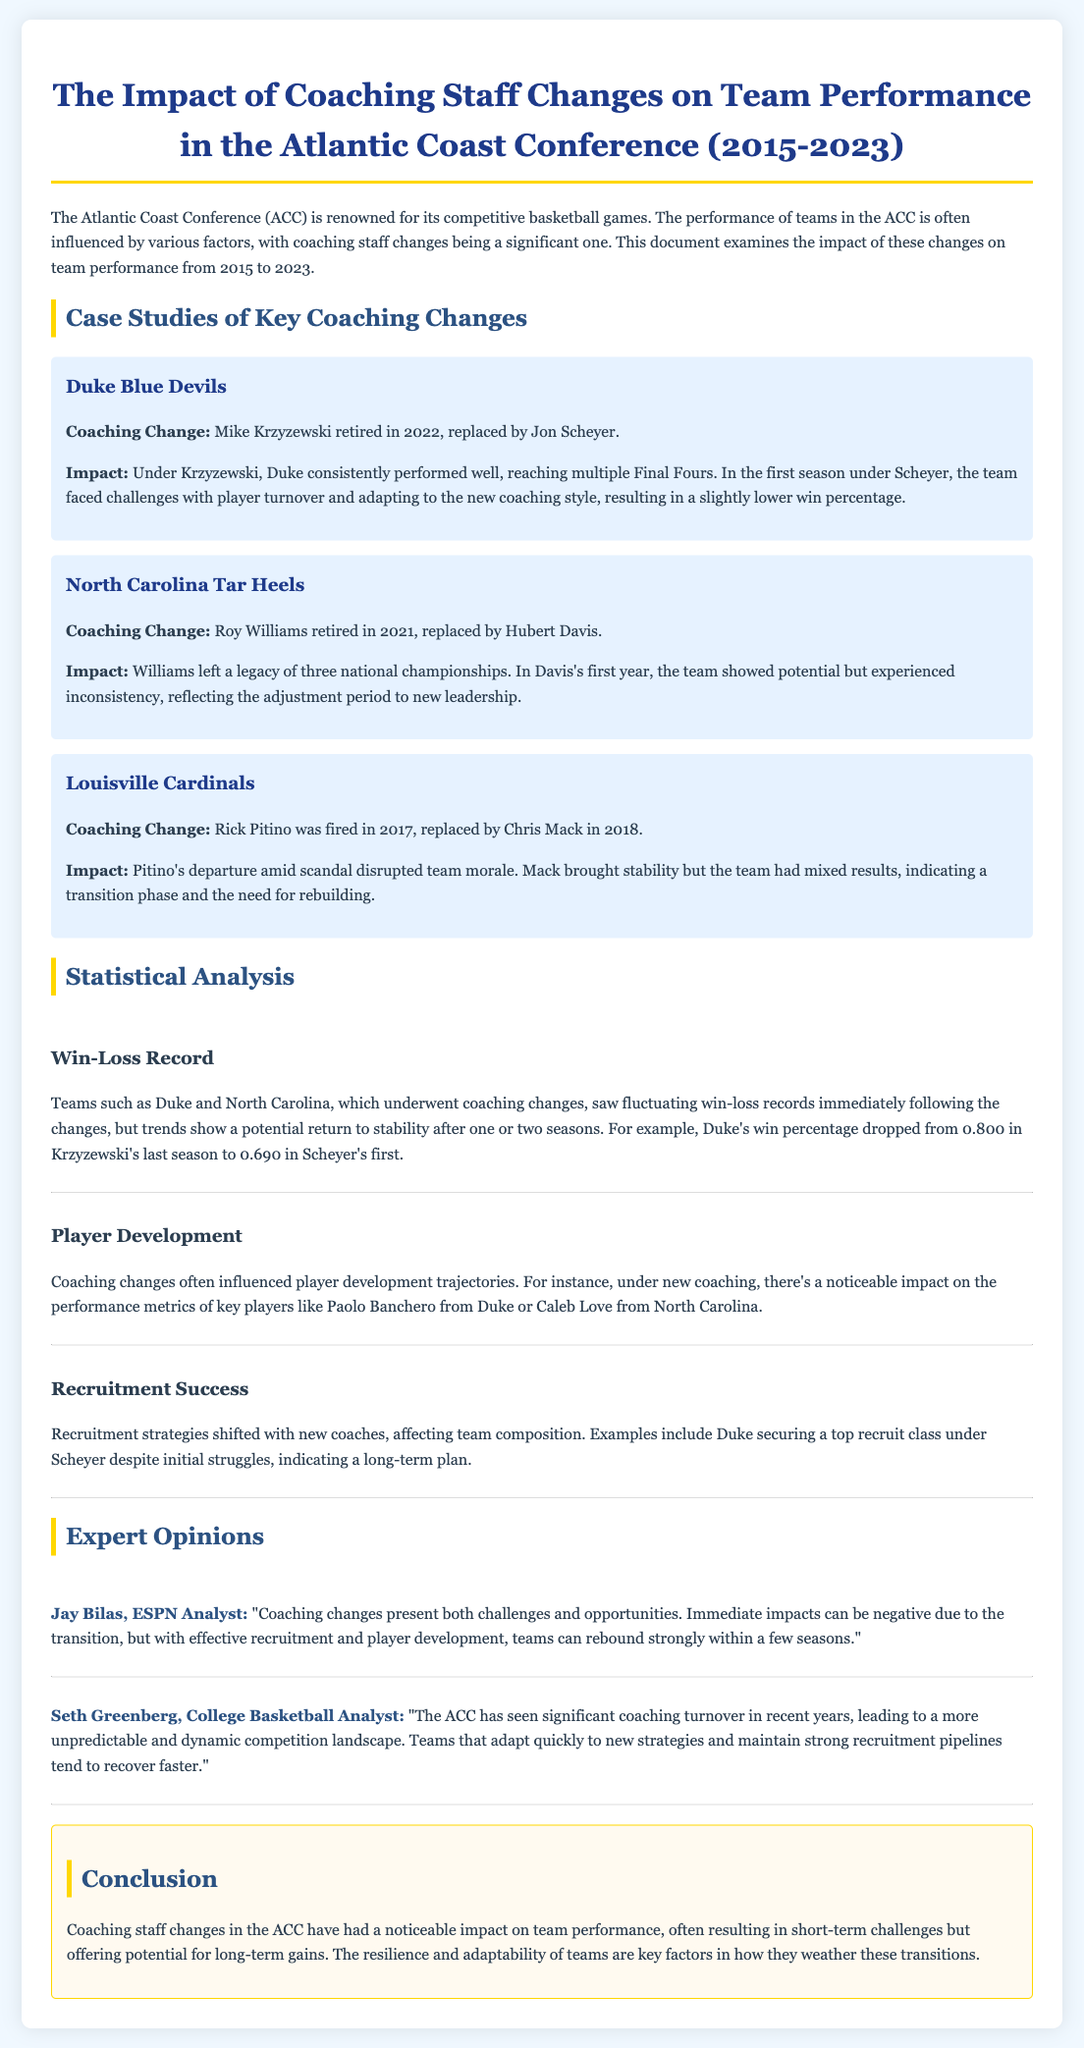what year did Mike Krzyzewski retire? The document states that Mike Krzyzewski retired in 2022.
Answer: 2022 what was Duke's win percentage in Scheyer's first season? According to the document, Duke's win percentage dropped to 0.690 in Scheyer's first season.
Answer: 0.690 how many national championships did Roy Williams win? The document mentions that Roy Williams left a legacy of three national championships.
Answer: three who replaced Rick Pitino as the head coach of Louisville? The document states that Chris Mack replaced Rick Pitino in 2018.
Answer: Chris Mack what did Jay Bilas say about coaching changes? According to Jay Bilas, coaching changes present both challenges and opportunities.
Answer: challenges and opportunities what impact did coaching changes have on player development? The document indicates that coaching changes often influenced player development trajectories.
Answer: influenced player development what does the document mention about recruitment strategies? It states that recruitment strategies shifted with new coaches, affecting team composition.
Answer: shifted with new coaches what is the conclusion about the impact of coaching staff changes? The conclusion states that coaching staff changes often result in short-term challenges but offer potential for long-term gains.
Answer: short-term challenges but offer potential for long-term gains 